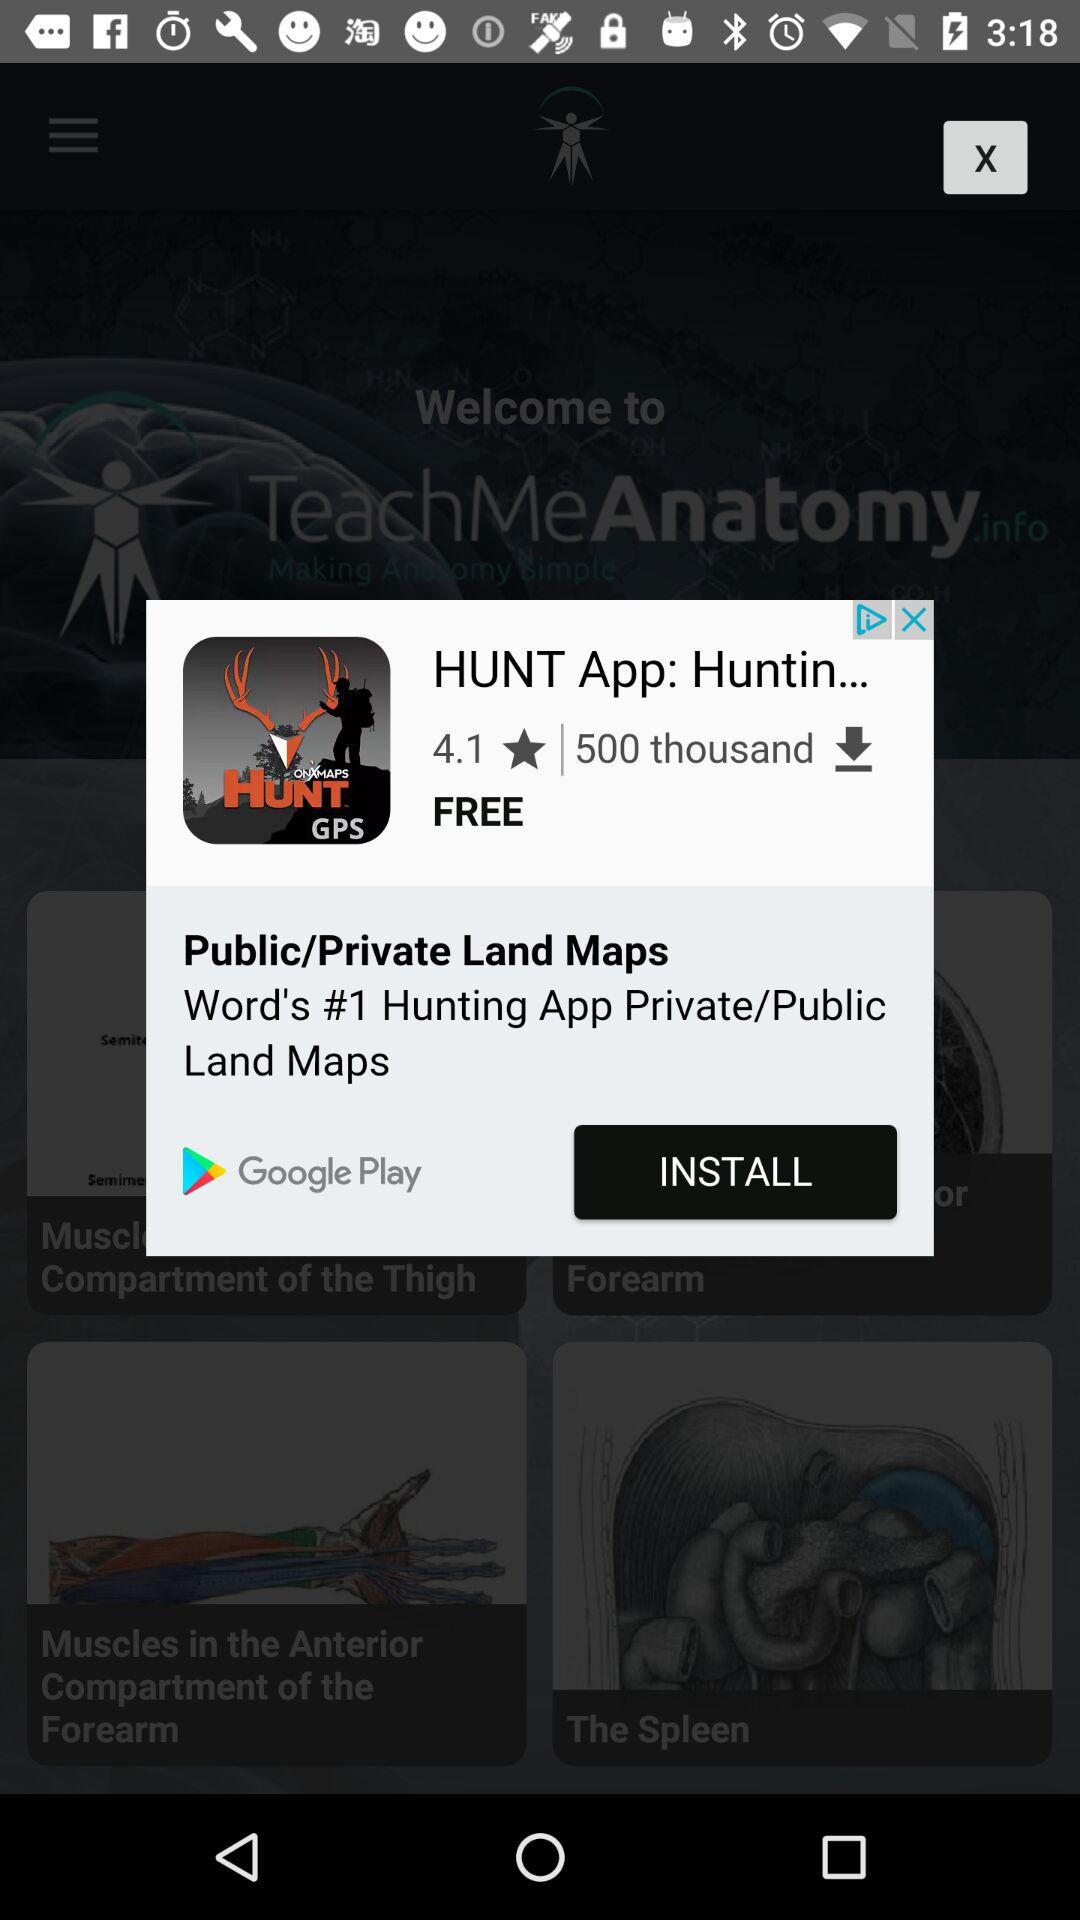Which version of "TeachMeAnatomy" is this?
When the provided information is insufficient, respond with <no answer>. <no answer> 